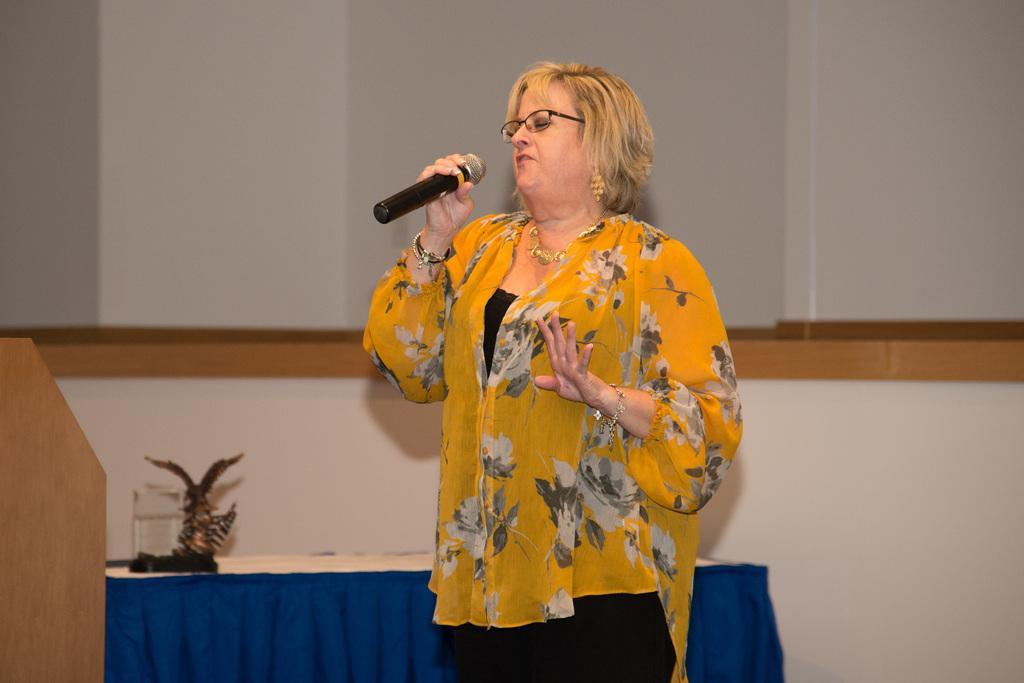In one or two sentences, can you explain what this image depicts? In this picture there is a woman standing and talking and she is holding the microphone. On the left side of the image there is a podium and there are objects on the table. At the back there is a wall. 